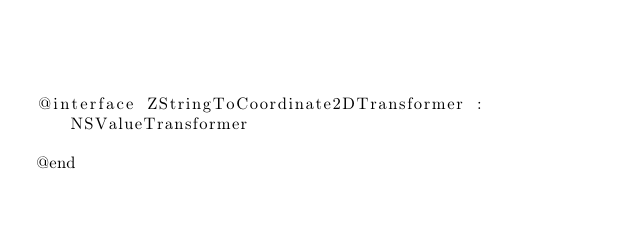<code> <loc_0><loc_0><loc_500><loc_500><_C_>


@interface ZStringToCoordinate2DTransformer : NSValueTransformer

@end</code> 